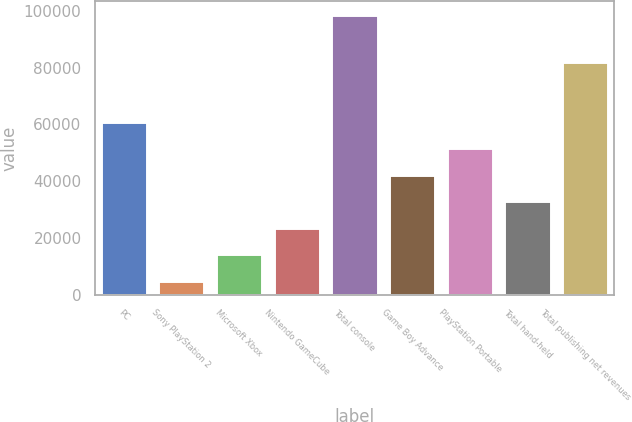Convert chart. <chart><loc_0><loc_0><loc_500><loc_500><bar_chart><fcel>PC<fcel>Sony PlayStation 2<fcel>Microsoft Xbox<fcel>Nintendo GameCube<fcel>Total console<fcel>Game Boy Advance<fcel>PlayStation Portable<fcel>Total hand-held<fcel>Total publishing net revenues<nl><fcel>61010.4<fcel>4929<fcel>14275.9<fcel>23622.8<fcel>98398<fcel>42316.6<fcel>51663.5<fcel>32969.7<fcel>81934<nl></chart> 